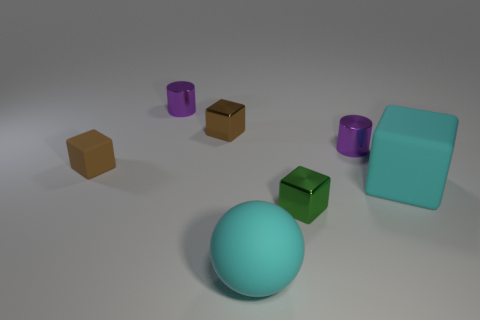The tiny purple cylinder that is in front of the tiny purple cylinder to the left of the cyan matte sphere is made of what material?
Provide a succinct answer. Metal. Do the small brown metal object and the cyan thing that is behind the cyan ball have the same shape?
Provide a succinct answer. Yes. How many matte objects are purple objects or green blocks?
Give a very brief answer. 0. The tiny cylinder to the right of the small cube that is in front of the big cyan object that is behind the small green metallic thing is what color?
Ensure brevity in your answer.  Purple. How many other objects are there of the same material as the sphere?
Make the answer very short. 2. Is the shape of the large cyan rubber object that is in front of the large cube the same as  the green object?
Make the answer very short. No. How many large things are balls or cyan objects?
Your answer should be very brief. 2. Are there an equal number of small purple things that are to the right of the small brown metallic thing and cyan rubber objects behind the green object?
Provide a succinct answer. Yes. Does the large matte sphere have the same color as the shiny object in front of the big rubber cube?
Offer a terse response. No. How many cyan objects are either cubes or big rubber objects?
Keep it short and to the point. 2. 